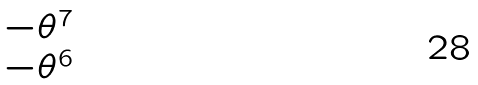<formula> <loc_0><loc_0><loc_500><loc_500>\begin{matrix} - \theta ^ { 7 } \\ - \theta ^ { 6 } \end{matrix}</formula> 